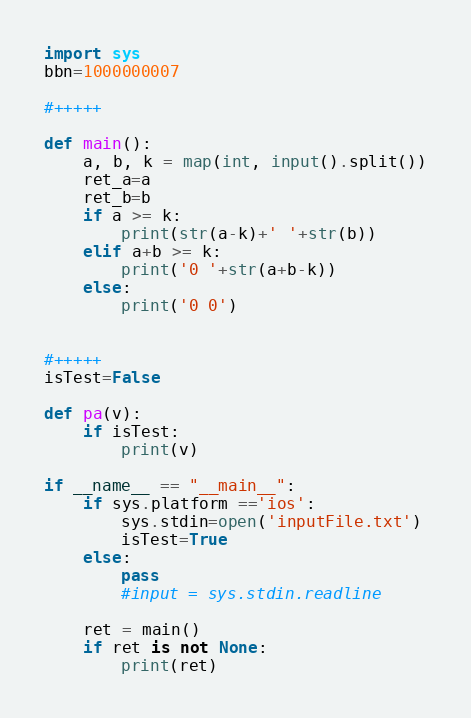Convert code to text. <code><loc_0><loc_0><loc_500><loc_500><_Python_>import sys
bbn=1000000007
	
#+++++
		
def main():
	a, b, k = map(int, input().split())
	ret_a=a
	ret_b=b
	if a >= k:
		print(str(a-k)+' '+str(b))
	elif a+b >= k:
		print('0 '+str(a+b-k))
	else:
		print('0 0')
	
	
#+++++
isTest=False

def pa(v):
	if isTest:
		print(v)

if __name__ == "__main__":
	if sys.platform =='ios':
		sys.stdin=open('inputFile.txt')
		isTest=True
	else:
		pass
		#input = sys.stdin.readline
			
	ret = main()
	if ret is not None:
		print(ret)</code> 